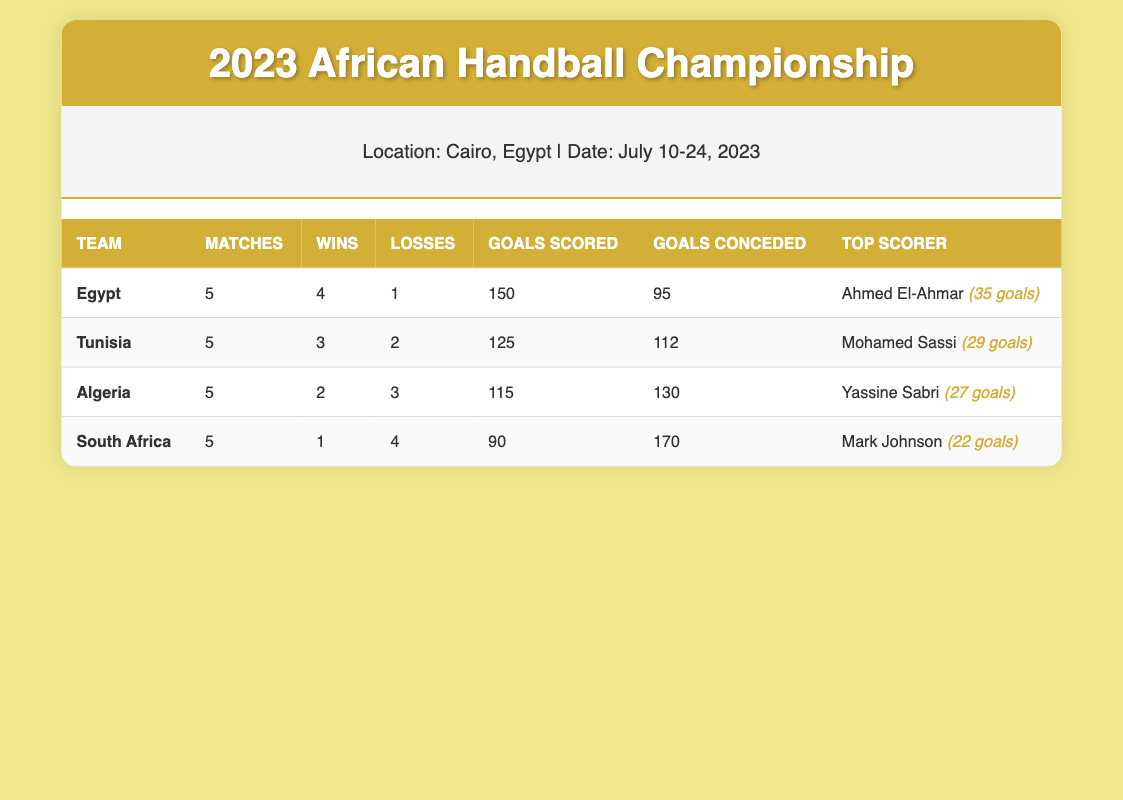What was Egypt's total number of goals scored in the tournament? From the table, Egypt scored a total of 150 goals in the tournament, as listed under the "Goals Scored" column for Egypt.
Answer: 150 How many matches did Tunisia win? According to the table, Tunisia won 3 matches, as indicated in the column for "Wins" next to Tunisia's name.
Answer: 3 Which team had the highest goals conceded? Looking at the "Goals Conceded" column, South Africa has the highest number of goals conceded, with a total of 170.
Answer: South Africa What is the difference in the number of wins between Egypt and Algeria? Egypt has 4 wins and Algeria has 2 wins. The difference in their wins is calculated as 4 - 2 = 2.
Answer: 2 Did any team score more than 140 goals? By checking the "Goals Scored" column, we see that Egypt scored 150 goals and Tunisia scored 125 goals. Therefore, Egypt is the only team that scored more than 140 goals.
Answer: Yes Who scored the highest number of goals in the tournament? Looking at the "Top Scorer" row for each team, Ahmed El-Ahmar from Egypt scored 35 goals, which is the highest compared to the other players listed.
Answer: Ahmed El-Ahmar Which team had the most losses? Referring to the "Losses" column, South Africa had 4 losses, which is more than any other team in the tournament.
Answer: South Africa If we combine the goals scored by Algeria and South Africa, how many goals do they have in total? Algeria scored 115 goals and South Africa scored 90 goals. The total is calculated as 115 + 90 = 205.
Answer: 205 What percentage of their matches did Egypt win? Egypt won 4 out of 5 matches. To find the percentage, we calculate (4/5) * 100 = 80%.
Answer: 80% 